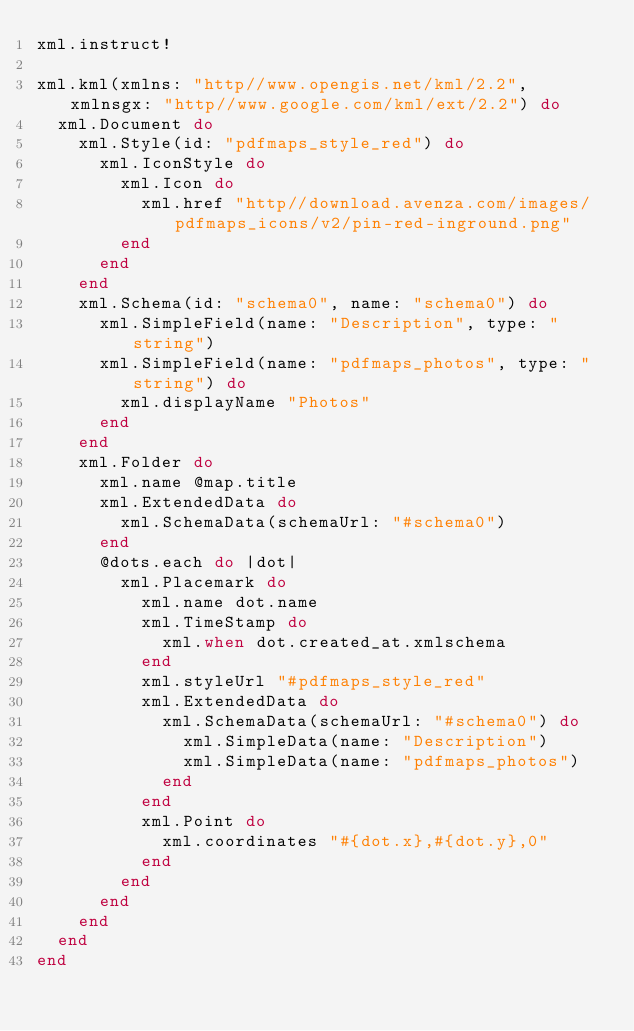Convert code to text. <code><loc_0><loc_0><loc_500><loc_500><_Ruby_>xml.instruct!

xml.kml(xmlns: "http//www.opengis.net/kml/2.2", xmlnsgx: "http//www.google.com/kml/ext/2.2") do
  xml.Document do
    xml.Style(id: "pdfmaps_style_red") do
      xml.IconStyle do
        xml.Icon do
          xml.href "http//download.avenza.com/images/pdfmaps_icons/v2/pin-red-inground.png"
        end
      end
    end
    xml.Schema(id: "schema0", name: "schema0") do
      xml.SimpleField(name: "Description", type: "string")
      xml.SimpleField(name: "pdfmaps_photos", type: "string") do
        xml.displayName "Photos"
      end
    end
    xml.Folder do
      xml.name @map.title
      xml.ExtendedData do
        xml.SchemaData(schemaUrl: "#schema0")
      end
      @dots.each do |dot|
        xml.Placemark do
          xml.name dot.name
          xml.TimeStamp do
            xml.when dot.created_at.xmlschema
          end
          xml.styleUrl "#pdfmaps_style_red"
          xml.ExtendedData do
            xml.SchemaData(schemaUrl: "#schema0") do
              xml.SimpleData(name: "Description")
              xml.SimpleData(name: "pdfmaps_photos")
            end
          end
          xml.Point do
            xml.coordinates "#{dot.x},#{dot.y},0"
          end
        end
      end
    end
  end
end
</code> 